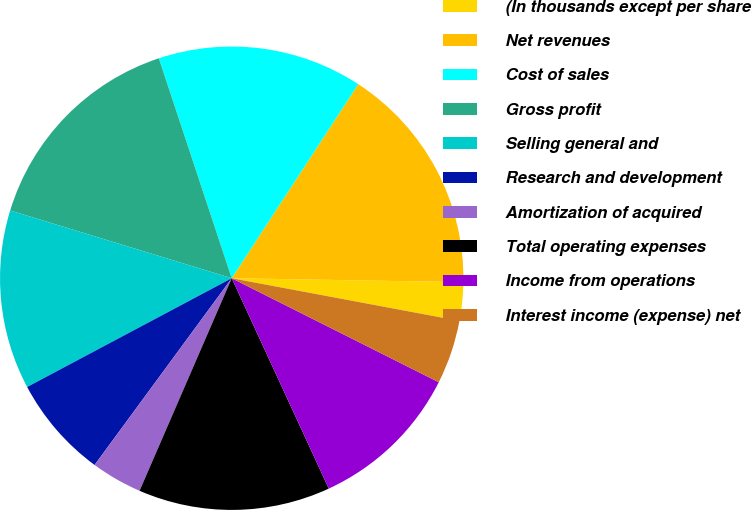Convert chart. <chart><loc_0><loc_0><loc_500><loc_500><pie_chart><fcel>(In thousands except per share<fcel>Net revenues<fcel>Cost of sales<fcel>Gross profit<fcel>Selling general and<fcel>Research and development<fcel>Amortization of acquired<fcel>Total operating expenses<fcel>Income from operations<fcel>Interest income (expense) net<nl><fcel>2.68%<fcel>16.07%<fcel>14.29%<fcel>15.18%<fcel>12.5%<fcel>7.14%<fcel>3.57%<fcel>13.39%<fcel>10.71%<fcel>4.46%<nl></chart> 